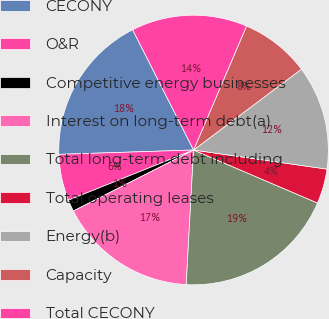<chart> <loc_0><loc_0><loc_500><loc_500><pie_chart><fcel>CECONY<fcel>O&R<fcel>Competitive energy businesses<fcel>Interest on long-term debt(a)<fcel>Total long-term debt including<fcel>Total operating leases<fcel>Energy(b)<fcel>Capacity<fcel>Total CECONY<nl><fcel>18.05%<fcel>5.56%<fcel>1.4%<fcel>16.66%<fcel>19.44%<fcel>4.17%<fcel>12.5%<fcel>8.34%<fcel>13.89%<nl></chart> 